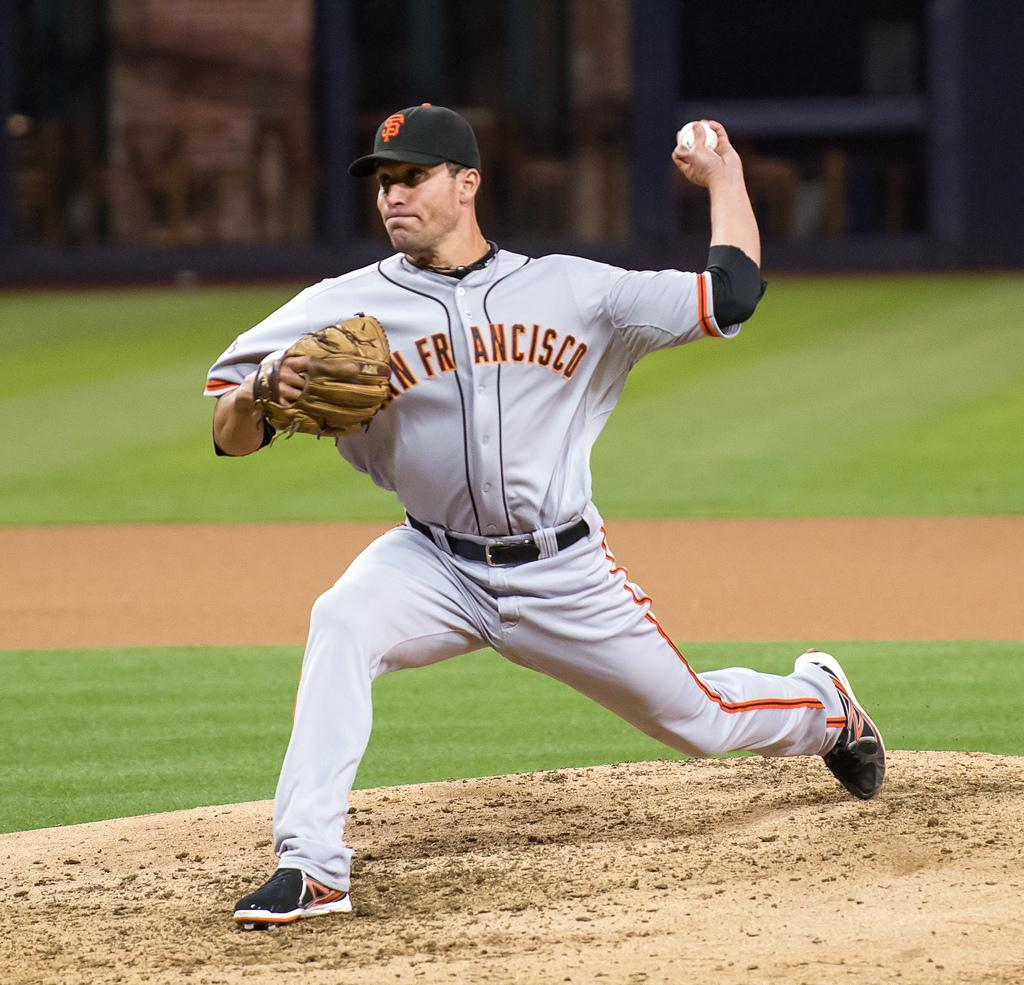<image>
Describe the image concisely. A pitcher in a San Francisco uniform gets ready to throw a ball. 